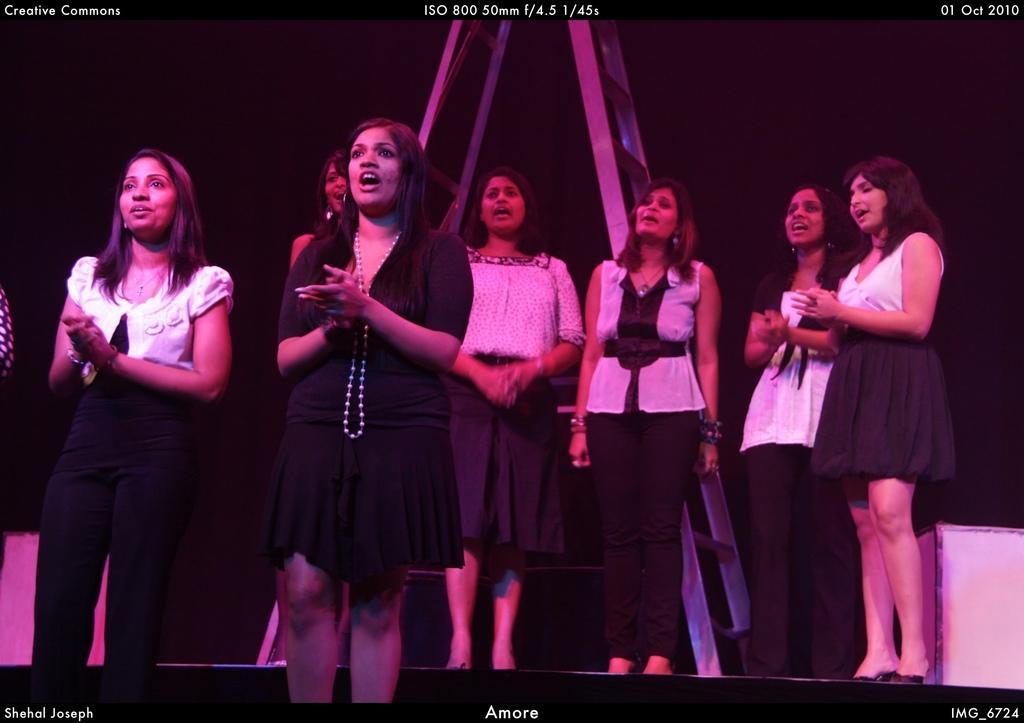Please provide a concise description of this image. In this image, we can see some women standing and we can see a ladder. 